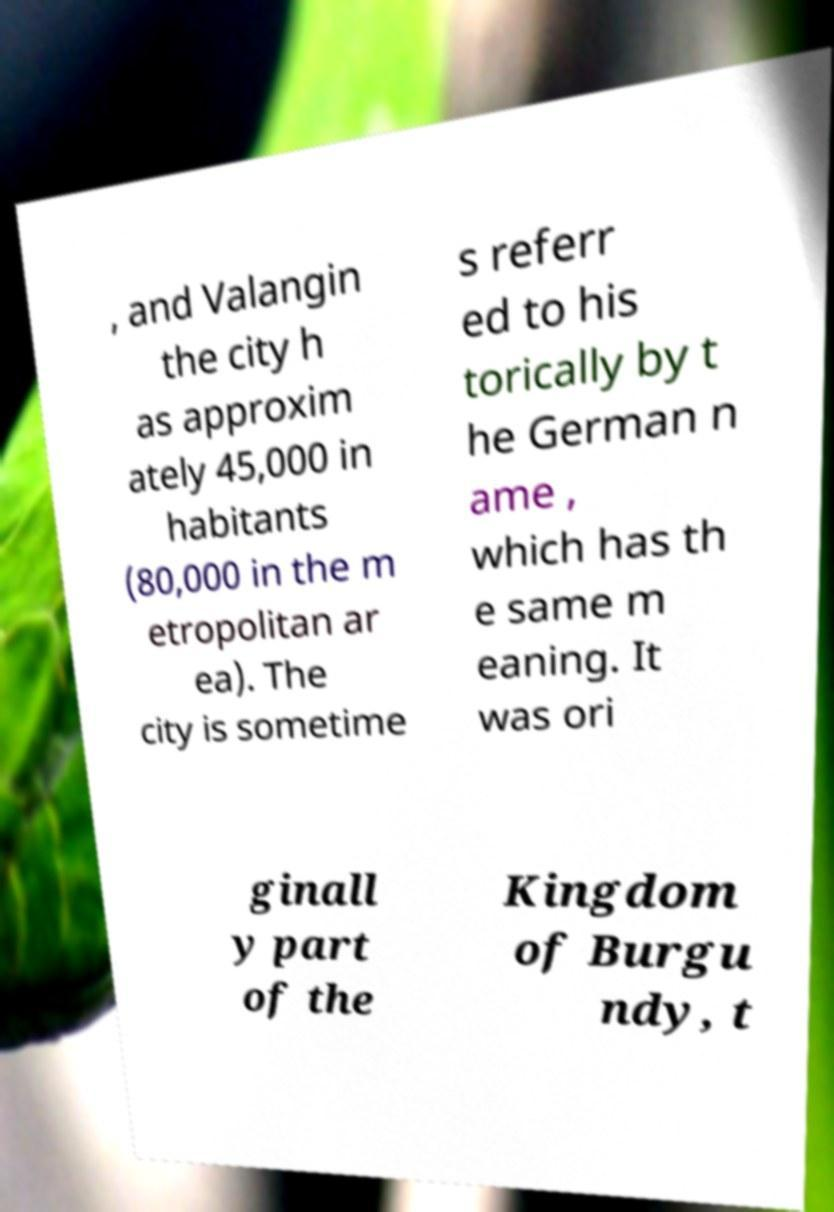Could you extract and type out the text from this image? , and Valangin the city h as approxim ately 45,000 in habitants (80,000 in the m etropolitan ar ea). The city is sometime s referr ed to his torically by t he German n ame , which has th e same m eaning. It was ori ginall y part of the Kingdom of Burgu ndy, t 